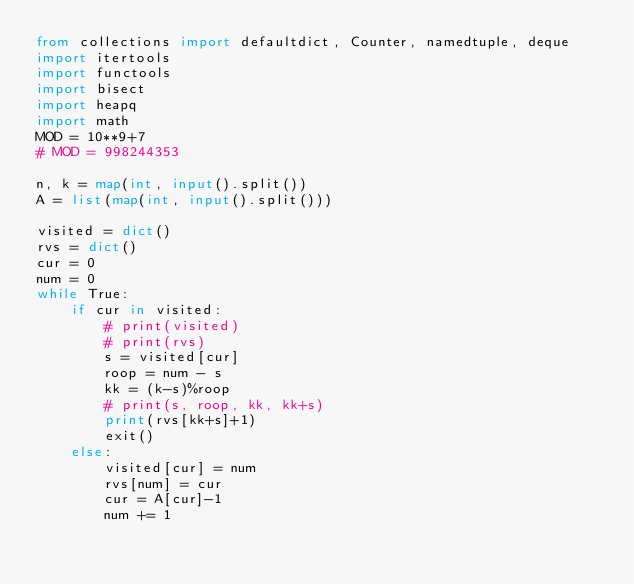Convert code to text. <code><loc_0><loc_0><loc_500><loc_500><_Python_>from collections import defaultdict, Counter, namedtuple, deque
import itertools
import functools
import bisect
import heapq
import math
MOD = 10**9+7
# MOD = 998244353

n, k = map(int, input().split())
A = list(map(int, input().split()))

visited = dict()
rvs = dict()
cur = 0
num = 0
while True:
    if cur in visited:
        # print(visited)
        # print(rvs)
        s = visited[cur]
        roop = num - s
        kk = (k-s)%roop
        # print(s, roop, kk, kk+s)
        print(rvs[kk+s]+1)
        exit()
    else:
        visited[cur] = num
        rvs[num] = cur
        cur = A[cur]-1
        num += 1

</code> 